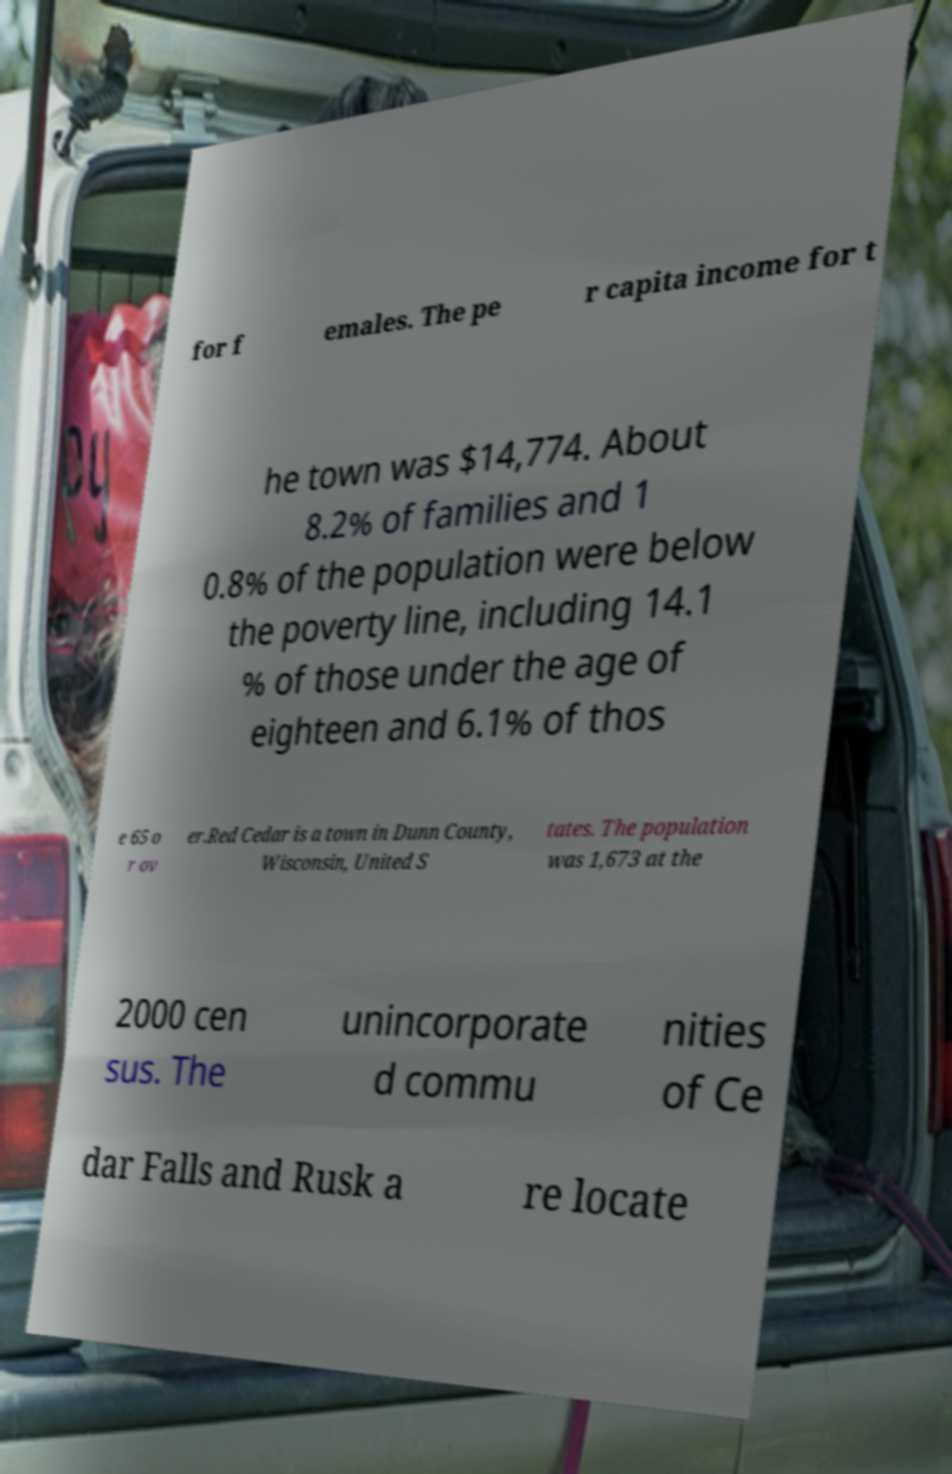Could you assist in decoding the text presented in this image and type it out clearly? for f emales. The pe r capita income for t he town was $14,774. About 8.2% of families and 1 0.8% of the population were below the poverty line, including 14.1 % of those under the age of eighteen and 6.1% of thos e 65 o r ov er.Red Cedar is a town in Dunn County, Wisconsin, United S tates. The population was 1,673 at the 2000 cen sus. The unincorporate d commu nities of Ce dar Falls and Rusk a re locate 